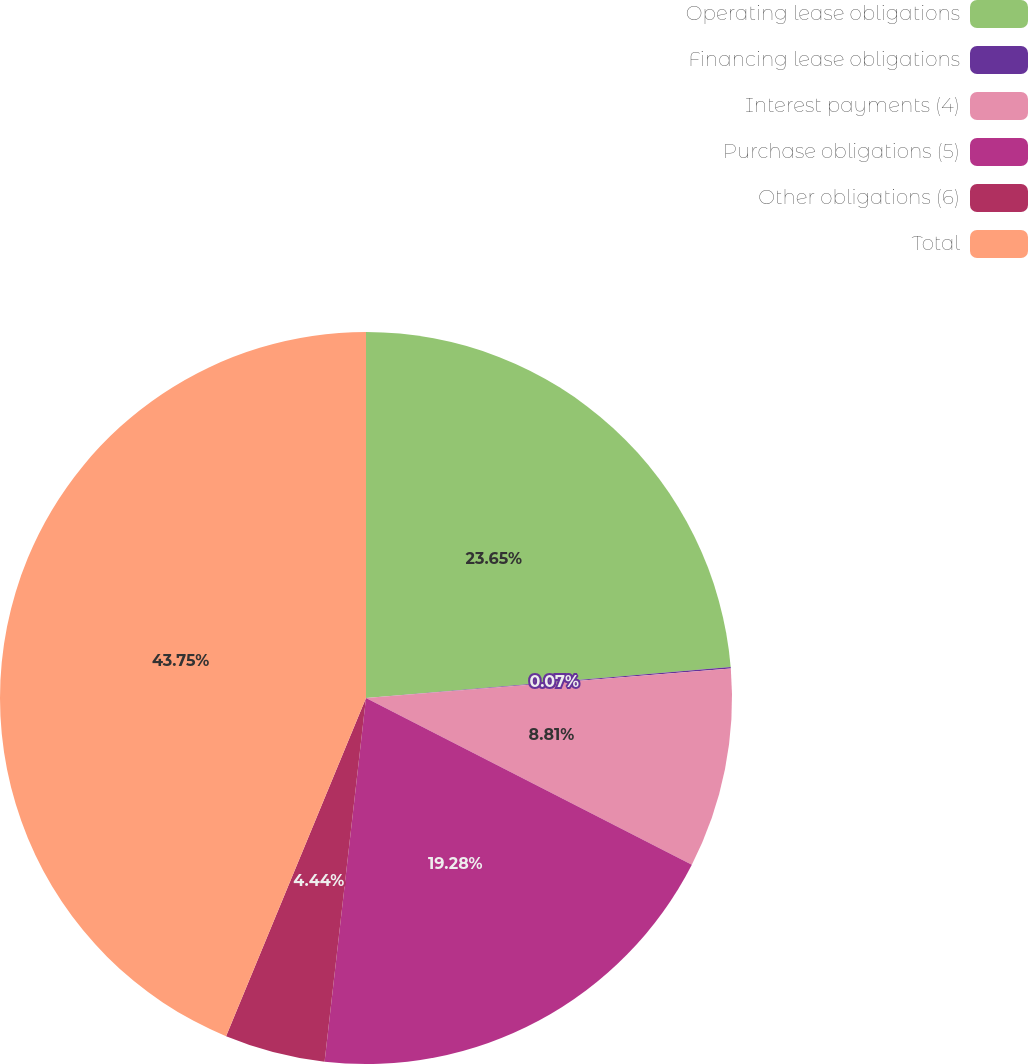Convert chart. <chart><loc_0><loc_0><loc_500><loc_500><pie_chart><fcel>Operating lease obligations<fcel>Financing lease obligations<fcel>Interest payments (4)<fcel>Purchase obligations (5)<fcel>Other obligations (6)<fcel>Total<nl><fcel>23.65%<fcel>0.07%<fcel>8.81%<fcel>19.28%<fcel>4.44%<fcel>43.76%<nl></chart> 